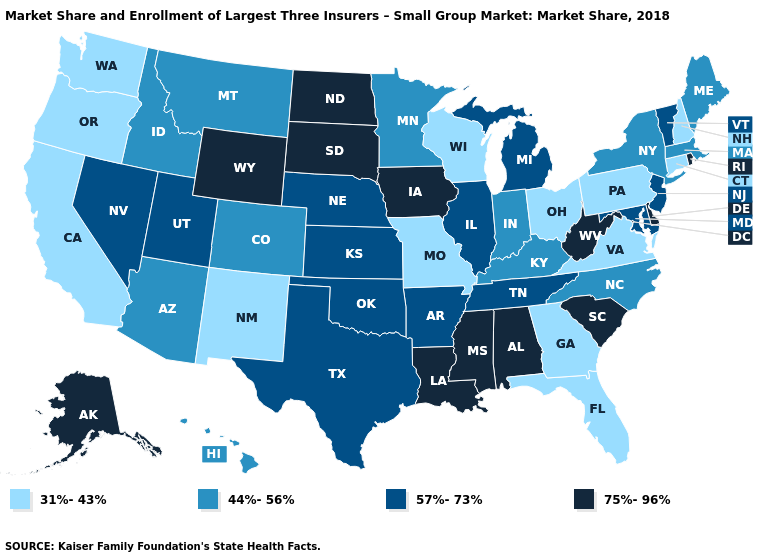Which states have the lowest value in the USA?
Answer briefly. California, Connecticut, Florida, Georgia, Missouri, New Hampshire, New Mexico, Ohio, Oregon, Pennsylvania, Virginia, Washington, Wisconsin. What is the lowest value in the USA?
Write a very short answer. 31%-43%. Does Connecticut have the lowest value in the USA?
Answer briefly. Yes. Is the legend a continuous bar?
Keep it brief. No. What is the highest value in the Northeast ?
Concise answer only. 75%-96%. Does the first symbol in the legend represent the smallest category?
Answer briefly. Yes. Among the states that border Indiana , does Ohio have the highest value?
Concise answer only. No. Name the states that have a value in the range 31%-43%?
Give a very brief answer. California, Connecticut, Florida, Georgia, Missouri, New Hampshire, New Mexico, Ohio, Oregon, Pennsylvania, Virginia, Washington, Wisconsin. What is the highest value in the USA?
Be succinct. 75%-96%. Name the states that have a value in the range 44%-56%?
Write a very short answer. Arizona, Colorado, Hawaii, Idaho, Indiana, Kentucky, Maine, Massachusetts, Minnesota, Montana, New York, North Carolina. How many symbols are there in the legend?
Quick response, please. 4. What is the value of Illinois?
Short answer required. 57%-73%. Does the map have missing data?
Quick response, please. No. Name the states that have a value in the range 75%-96%?
Be succinct. Alabama, Alaska, Delaware, Iowa, Louisiana, Mississippi, North Dakota, Rhode Island, South Carolina, South Dakota, West Virginia, Wyoming. Name the states that have a value in the range 75%-96%?
Give a very brief answer. Alabama, Alaska, Delaware, Iowa, Louisiana, Mississippi, North Dakota, Rhode Island, South Carolina, South Dakota, West Virginia, Wyoming. 